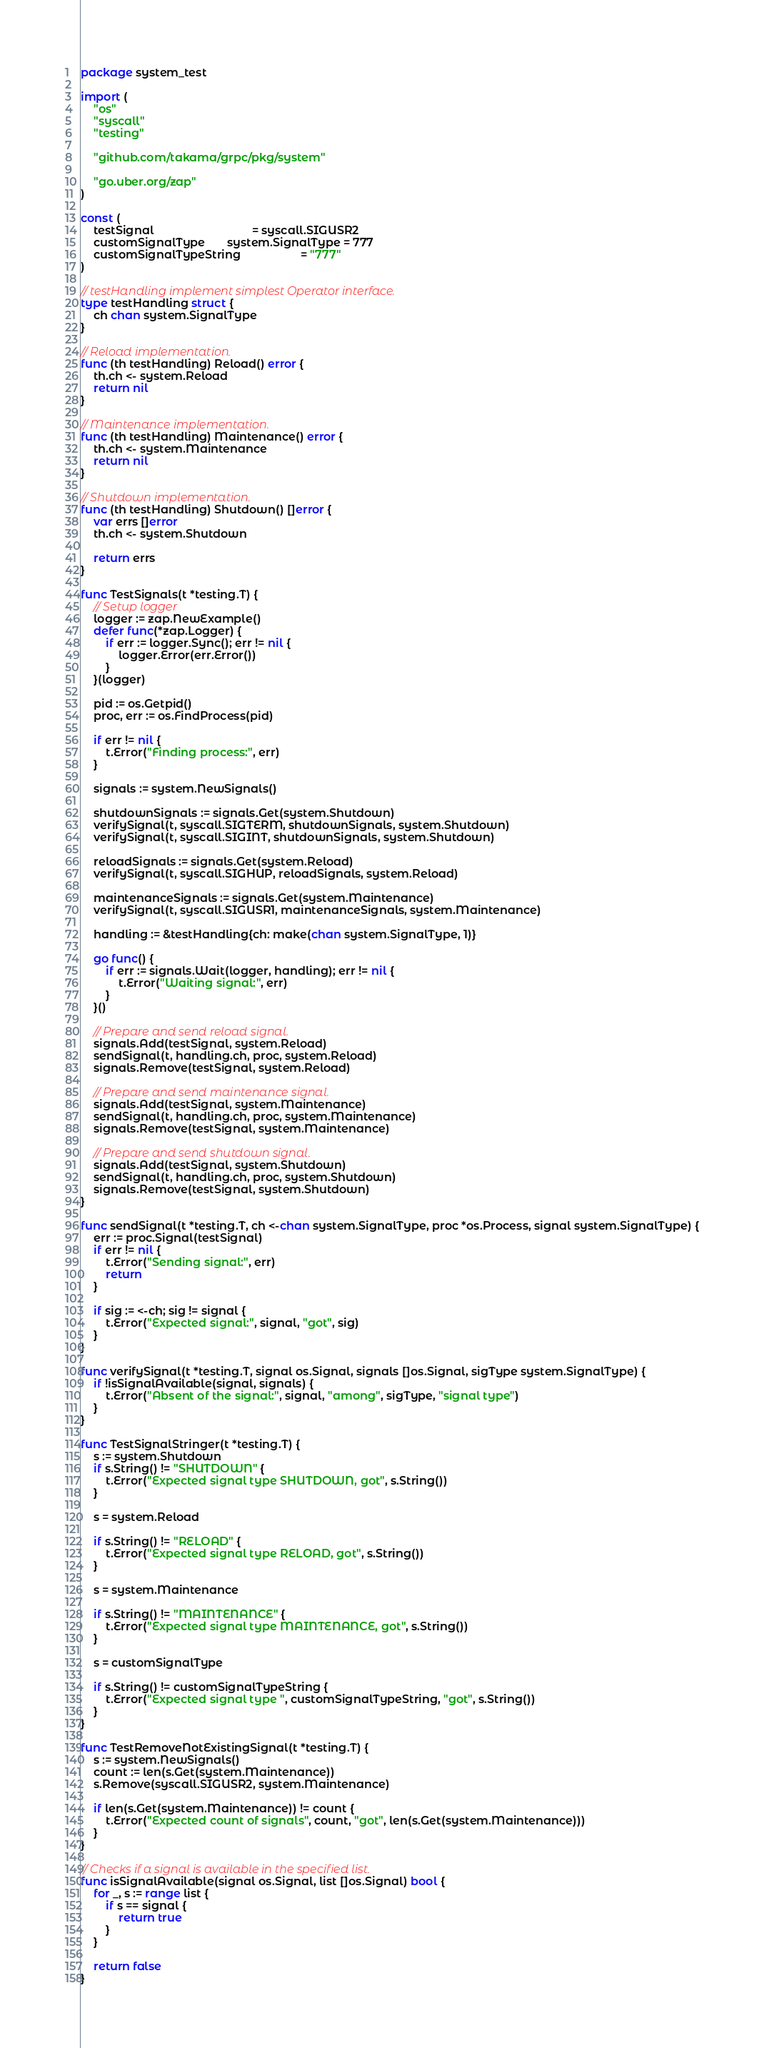Convert code to text. <code><loc_0><loc_0><loc_500><loc_500><_Go_>package system_test

import (
	"os"
	"syscall"
	"testing"

	"github.com/takama/grpc/pkg/system"

	"go.uber.org/zap"
)

const (
	testSignal                               = syscall.SIGUSR2
	customSignalType       system.SignalType = 777
	customSignalTypeString                   = "777"
)

// testHandling implement simplest Operator interface.
type testHandling struct {
	ch chan system.SignalType
}

// Reload implementation.
func (th testHandling) Reload() error {
	th.ch <- system.Reload
	return nil
}

// Maintenance implementation.
func (th testHandling) Maintenance() error {
	th.ch <- system.Maintenance
	return nil
}

// Shutdown implementation.
func (th testHandling) Shutdown() []error {
	var errs []error
	th.ch <- system.Shutdown

	return errs
}

func TestSignals(t *testing.T) {
	// Setup logger
	logger := zap.NewExample()
	defer func(*zap.Logger) {
		if err := logger.Sync(); err != nil {
			logger.Error(err.Error())
		}
	}(logger)

	pid := os.Getpid()
	proc, err := os.FindProcess(pid)

	if err != nil {
		t.Error("Finding process:", err)
	}

	signals := system.NewSignals()

	shutdownSignals := signals.Get(system.Shutdown)
	verifySignal(t, syscall.SIGTERM, shutdownSignals, system.Shutdown)
	verifySignal(t, syscall.SIGINT, shutdownSignals, system.Shutdown)

	reloadSignals := signals.Get(system.Reload)
	verifySignal(t, syscall.SIGHUP, reloadSignals, system.Reload)

	maintenanceSignals := signals.Get(system.Maintenance)
	verifySignal(t, syscall.SIGUSR1, maintenanceSignals, system.Maintenance)

	handling := &testHandling{ch: make(chan system.SignalType, 1)}

	go func() {
		if err := signals.Wait(logger, handling); err != nil {
			t.Error("Waiting signal:", err)
		}
	}()

	// Prepare and send reload signal.
	signals.Add(testSignal, system.Reload)
	sendSignal(t, handling.ch, proc, system.Reload)
	signals.Remove(testSignal, system.Reload)

	// Prepare and send maintenance signal.
	signals.Add(testSignal, system.Maintenance)
	sendSignal(t, handling.ch, proc, system.Maintenance)
	signals.Remove(testSignal, system.Maintenance)

	// Prepare and send shutdown signal.
	signals.Add(testSignal, system.Shutdown)
	sendSignal(t, handling.ch, proc, system.Shutdown)
	signals.Remove(testSignal, system.Shutdown)
}

func sendSignal(t *testing.T, ch <-chan system.SignalType, proc *os.Process, signal system.SignalType) {
	err := proc.Signal(testSignal)
	if err != nil {
		t.Error("Sending signal:", err)
		return
	}

	if sig := <-ch; sig != signal {
		t.Error("Expected signal:", signal, "got", sig)
	}
}

func verifySignal(t *testing.T, signal os.Signal, signals []os.Signal, sigType system.SignalType) {
	if !isSignalAvailable(signal, signals) {
		t.Error("Absent of the signal:", signal, "among", sigType, "signal type")
	}
}

func TestSignalStringer(t *testing.T) {
	s := system.Shutdown
	if s.String() != "SHUTDOWN" {
		t.Error("Expected signal type SHUTDOWN, got", s.String())
	}

	s = system.Reload

	if s.String() != "RELOAD" {
		t.Error("Expected signal type RELOAD, got", s.String())
	}

	s = system.Maintenance

	if s.String() != "MAINTENANCE" {
		t.Error("Expected signal type MAINTENANCE, got", s.String())
	}

	s = customSignalType

	if s.String() != customSignalTypeString {
		t.Error("Expected signal type ", customSignalTypeString, "got", s.String())
	}
}

func TestRemoveNotExistingSignal(t *testing.T) {
	s := system.NewSignals()
	count := len(s.Get(system.Maintenance))
	s.Remove(syscall.SIGUSR2, system.Maintenance)

	if len(s.Get(system.Maintenance)) != count {
		t.Error("Expected count of signals", count, "got", len(s.Get(system.Maintenance)))
	}
}

// Checks if a signal is available in the specified list.
func isSignalAvailable(signal os.Signal, list []os.Signal) bool {
	for _, s := range list {
		if s == signal {
			return true
		}
	}

	return false
}
</code> 